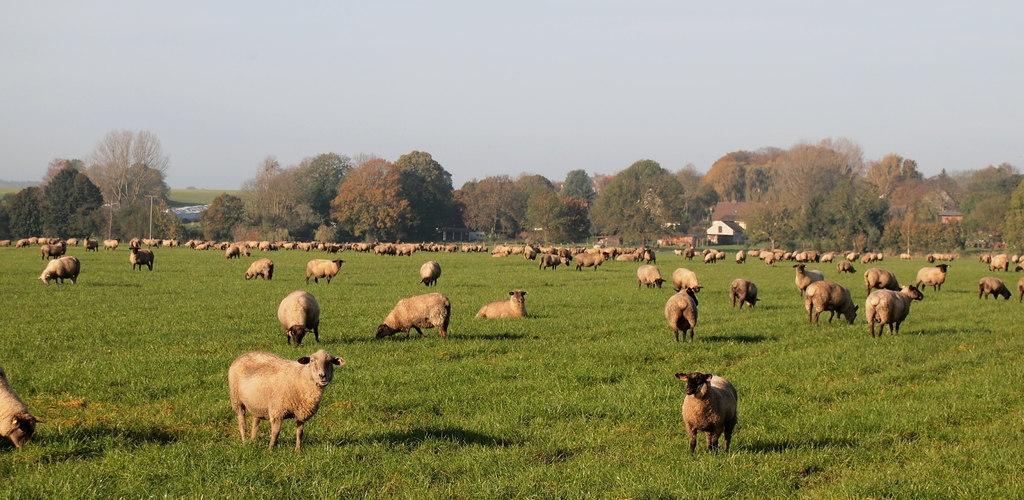Describe this image in one or two sentences. In this image, there are a few animals. We can see the ground with grass. We can see some trees, houses. We can also see the sky. 